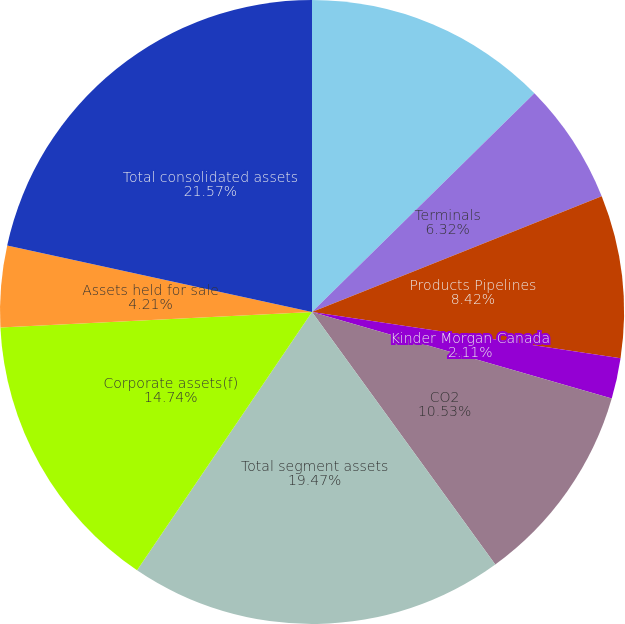<chart> <loc_0><loc_0><loc_500><loc_500><pie_chart><fcel>Natural Gas Pipelines<fcel>Terminals<fcel>Products Pipelines<fcel>Kinder Morgan Canada<fcel>Other<fcel>CO2<fcel>Total segment assets<fcel>Corporate assets(f)<fcel>Assets held for sale<fcel>Total consolidated assets<nl><fcel>12.63%<fcel>6.32%<fcel>8.42%<fcel>2.11%<fcel>0.0%<fcel>10.53%<fcel>19.47%<fcel>14.74%<fcel>4.21%<fcel>21.58%<nl></chart> 